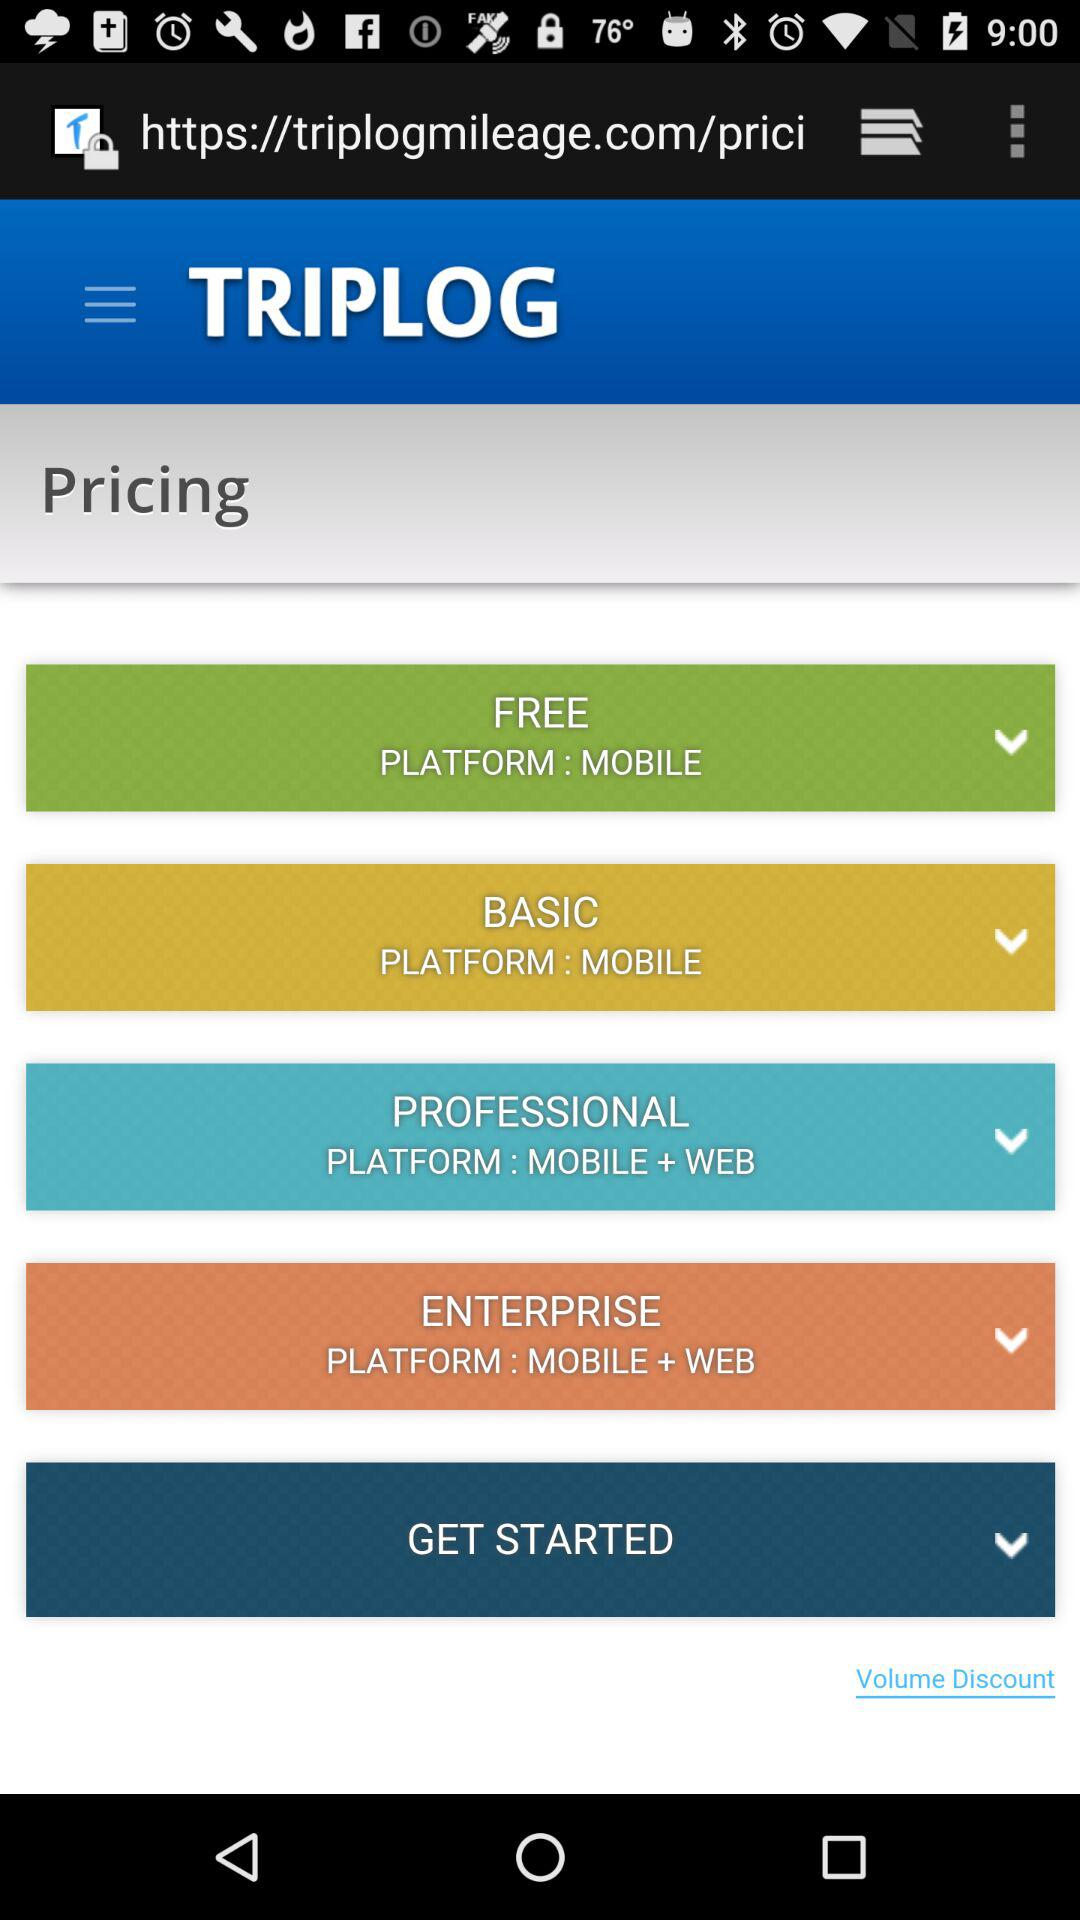What is the name of the application? The name of the application is "TRIPLOG". 